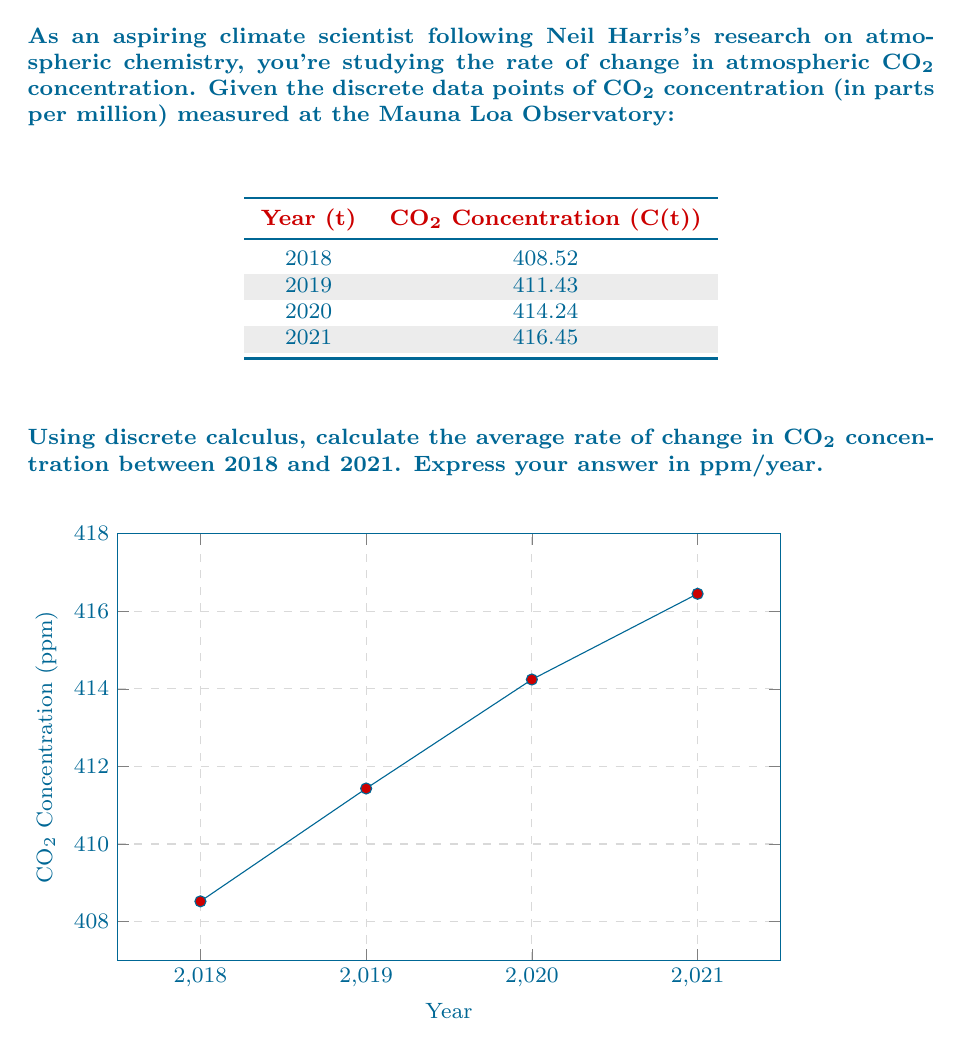Help me with this question. To calculate the average rate of change using discrete calculus, we'll use the concept of the discrete derivative. The average rate of change over an interval is given by the difference quotient:

$$\frac{\Delta C}{\Delta t} = \frac{C(t_f) - C(t_i)}{t_f - t_i}$$

Where:
- $C(t_f)$ is the final concentration
- $C(t_i)$ is the initial concentration
- $t_f$ is the final time
- $t_i$ is the initial time

Given data:
- $C(2018) = 408.52$ ppm
- $C(2021) = 416.45$ ppm
- $t_i = 2018$
- $t_f = 2021$

Step 1: Calculate the change in concentration
$$\Delta C = C(2021) - C(2018) = 416.45 - 408.52 = 7.93 \text{ ppm}$$

Step 2: Calculate the time interval
$$\Delta t = 2021 - 2018 = 3 \text{ years}$$

Step 3: Apply the difference quotient formula
$$\frac{\Delta C}{\Delta t} = \frac{7.93 \text{ ppm}}{3 \text{ years}} = 2.64333... \text{ ppm/year}$$

Step 4: Round to two decimal places for precision commonly used in atmospheric science
$$\frac{\Delta C}{\Delta t} \approx 2.64 \text{ ppm/year}$$

This result represents the average annual increase in CO₂ concentration over the given period.
Answer: $2.64 \text{ ppm/year}$ 